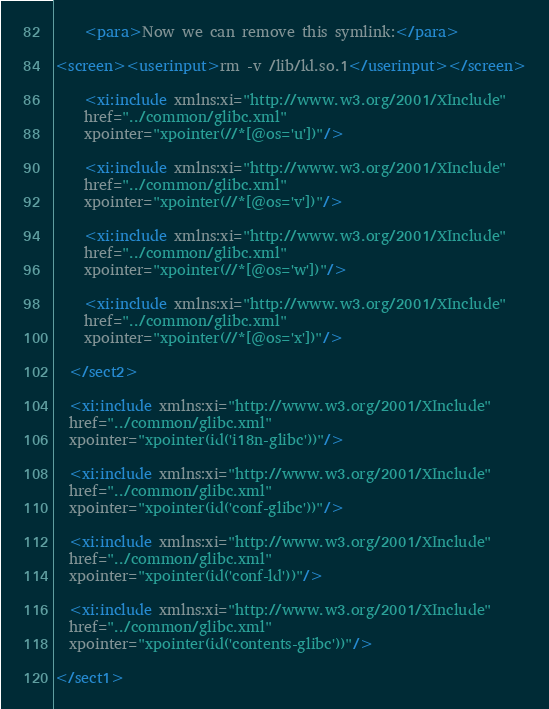<code> <loc_0><loc_0><loc_500><loc_500><_XML_>
    <para>Now we can remove this symlink:</para>

<screen><userinput>rm -v /lib/ld.so.1</userinput></screen>

    <xi:include xmlns:xi="http://www.w3.org/2001/XInclude"
    href="../common/glibc.xml"
    xpointer="xpointer(//*[@os='u'])"/>

    <xi:include xmlns:xi="http://www.w3.org/2001/XInclude"
    href="../common/glibc.xml"
    xpointer="xpointer(//*[@os='v'])"/>

    <xi:include xmlns:xi="http://www.w3.org/2001/XInclude"
    href="../common/glibc.xml"
    xpointer="xpointer(//*[@os='w'])"/>

    <xi:include xmlns:xi="http://www.w3.org/2001/XInclude"
    href="../common/glibc.xml"
    xpointer="xpointer(//*[@os='x'])"/>

  </sect2>

  <xi:include xmlns:xi="http://www.w3.org/2001/XInclude"
  href="../common/glibc.xml"
  xpointer="xpointer(id('i18n-glibc'))"/>

  <xi:include xmlns:xi="http://www.w3.org/2001/XInclude"
  href="../common/glibc.xml"
  xpointer="xpointer(id('conf-glibc'))"/>

  <xi:include xmlns:xi="http://www.w3.org/2001/XInclude"
  href="../common/glibc.xml"
  xpointer="xpointer(id('conf-ld'))"/>

  <xi:include xmlns:xi="http://www.w3.org/2001/XInclude"
  href="../common/glibc.xml"
  xpointer="xpointer(id('contents-glibc'))"/>

</sect1>
</code> 